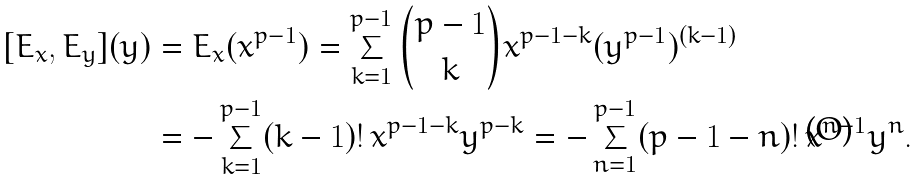Convert formula to latex. <formula><loc_0><loc_0><loc_500><loc_500>[ E _ { x } , E _ { y } ] ( y ) & = E _ { x } ( x ^ { p - 1 } ) = \sum _ { k = 1 } ^ { p - 1 } { { p - 1 } \choose k } x ^ { p - 1 - k } ( y ^ { p - 1 } ) ^ { ( k - 1 ) } \\ & = - \sum _ { k = 1 } ^ { p - 1 } ( k - 1 ) ! \, x ^ { p - 1 - k } y ^ { p - k } = - \sum _ { n = 1 } ^ { p - 1 } ( p - 1 - n ) ! \, x ^ { n - 1 } y ^ { n } .</formula> 